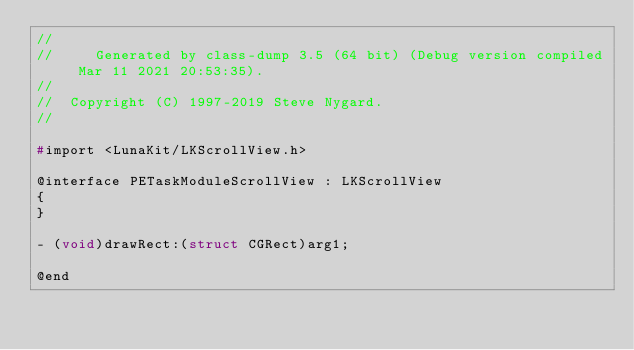Convert code to text. <code><loc_0><loc_0><loc_500><loc_500><_C_>//
//     Generated by class-dump 3.5 (64 bit) (Debug version compiled Mar 11 2021 20:53:35).
//
//  Copyright (C) 1997-2019 Steve Nygard.
//

#import <LunaKit/LKScrollView.h>

@interface PETaskModuleScrollView : LKScrollView
{
}

- (void)drawRect:(struct CGRect)arg1;

@end

</code> 